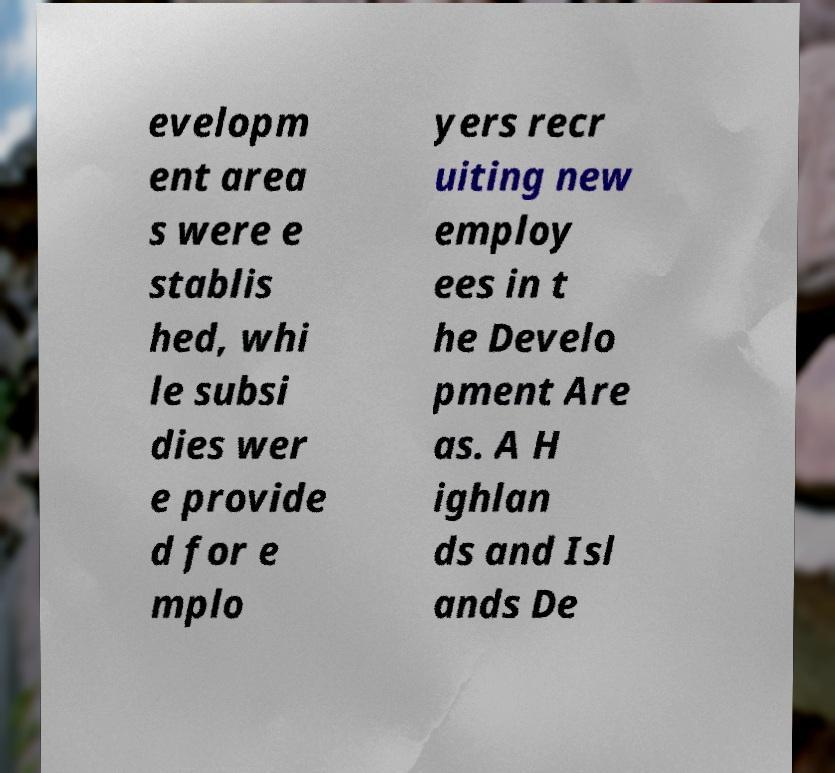Could you extract and type out the text from this image? evelopm ent area s were e stablis hed, whi le subsi dies wer e provide d for e mplo yers recr uiting new employ ees in t he Develo pment Are as. A H ighlan ds and Isl ands De 